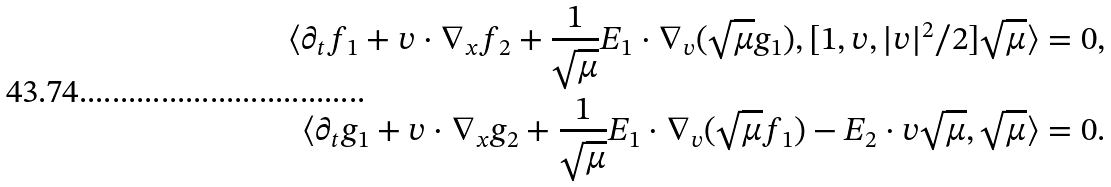<formula> <loc_0><loc_0><loc_500><loc_500>\langle \partial _ { t } f _ { 1 } + v \cdot \nabla _ { x } f _ { 2 } + \frac { 1 } { \sqrt { \mu } } E _ { 1 } \cdot \nabla _ { v } ( \sqrt { \mu } g _ { 1 } ) , [ 1 , v , | v | ^ { 2 } / 2 ] \sqrt { \mu } \rangle & = 0 , \\ \langle \partial _ { t } g _ { 1 } + v \cdot \nabla _ { x } g _ { 2 } + \frac { 1 } { \sqrt { \mu } } E _ { 1 } \cdot \nabla _ { v } ( \sqrt { \mu } f _ { 1 } ) - E _ { 2 } \cdot v \sqrt { \mu } , \sqrt { \mu } \rangle & = 0 . \\</formula> 